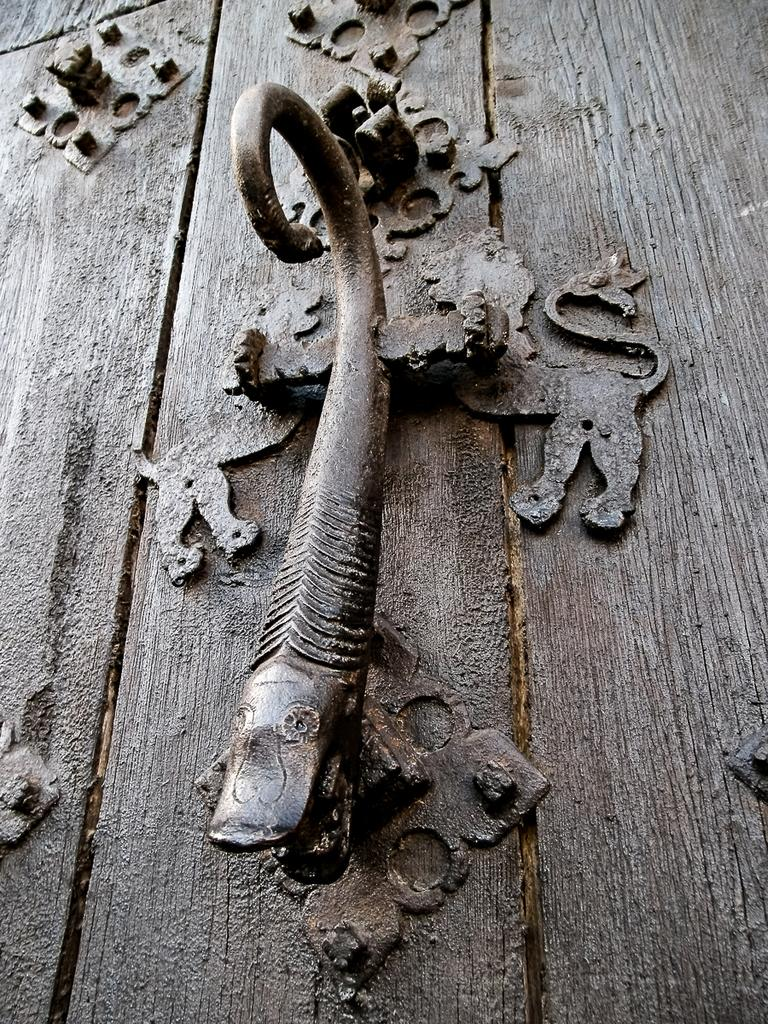What is the main subject of the image? There is a sculpture in the image. Can you describe the sculpture? Unfortunately, the description of the sculpture is not provided in the facts. What other objects can be seen in the image besides the sculpture? There is a wooden object in the image. How many bikes are parked next to the sculpture in the image? There is no mention of bikes in the image, so we cannot determine how many bikes are present. Is there any coal visible near the wooden object in the image? There is no mention of coal in the image, so we cannot determine if it is present. 